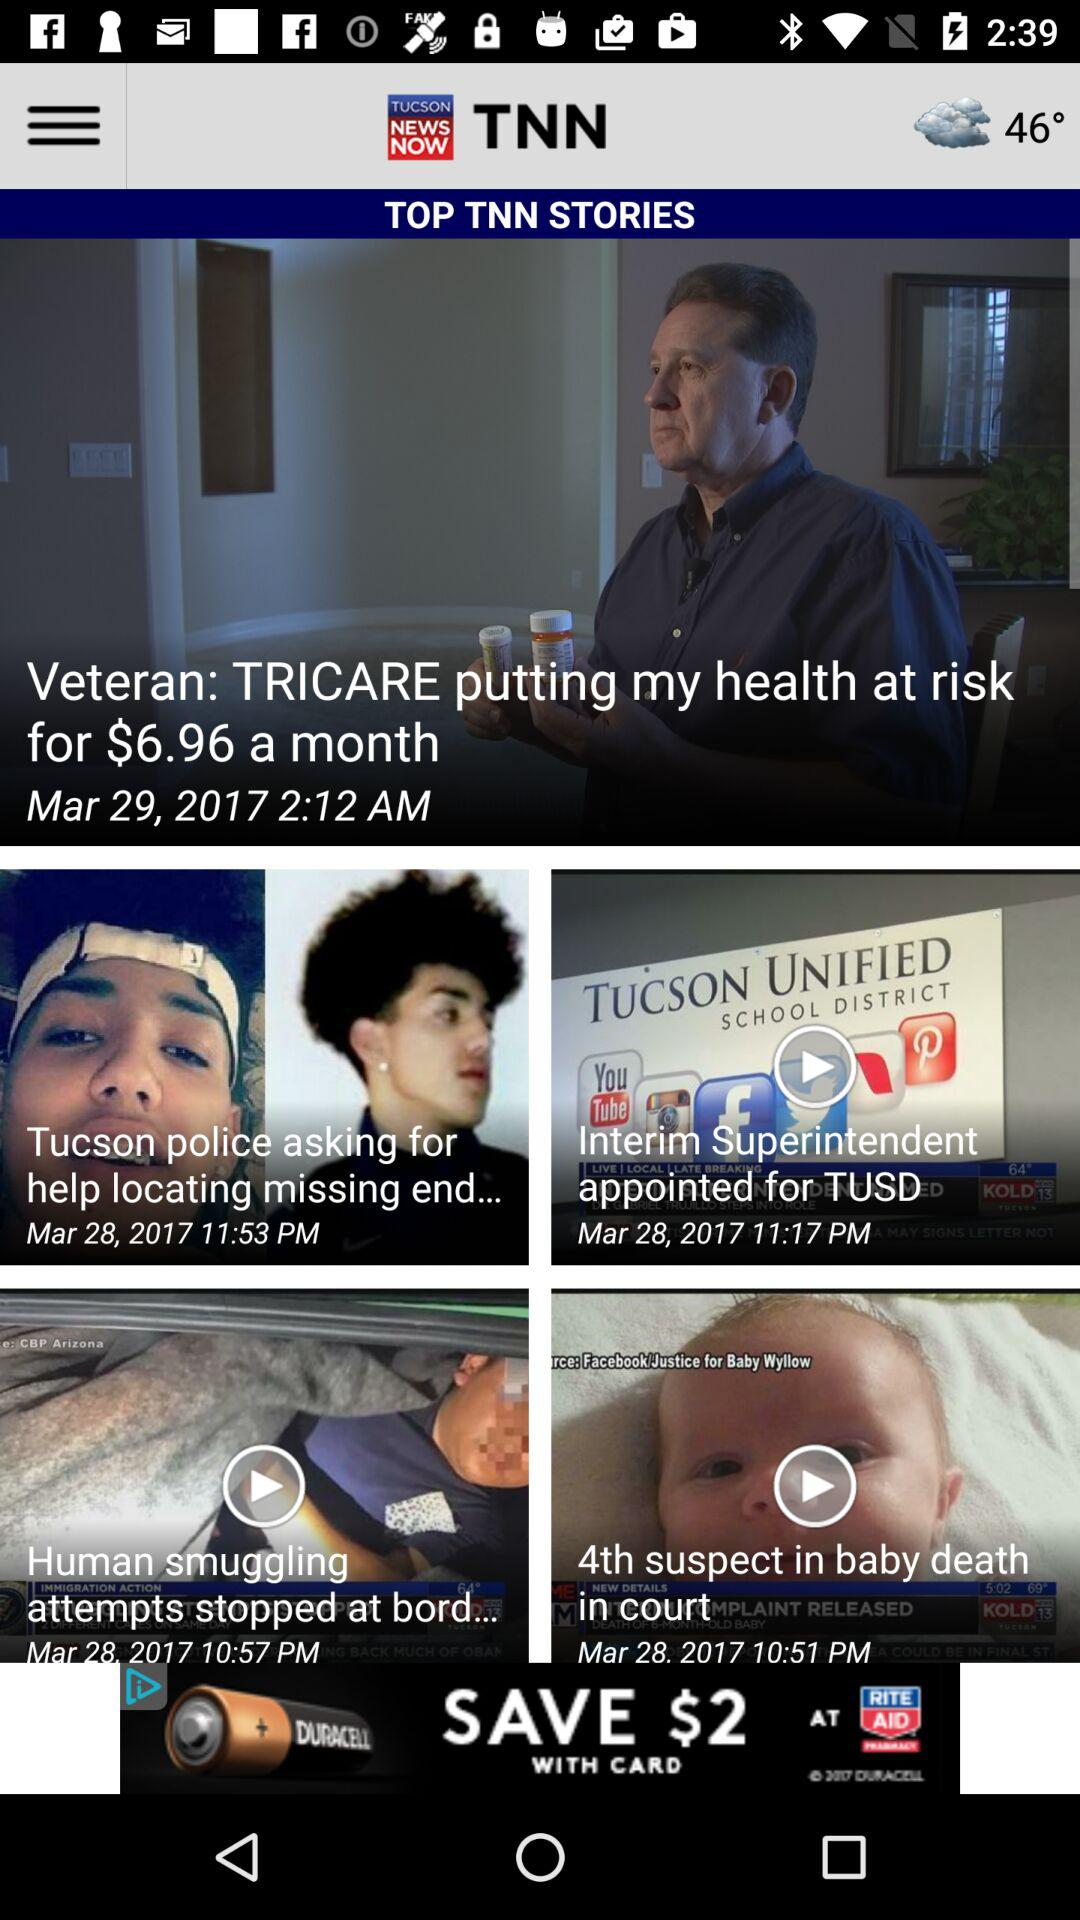What is the name of the application? The name of the application is "TUCSON NEWS NOW". 